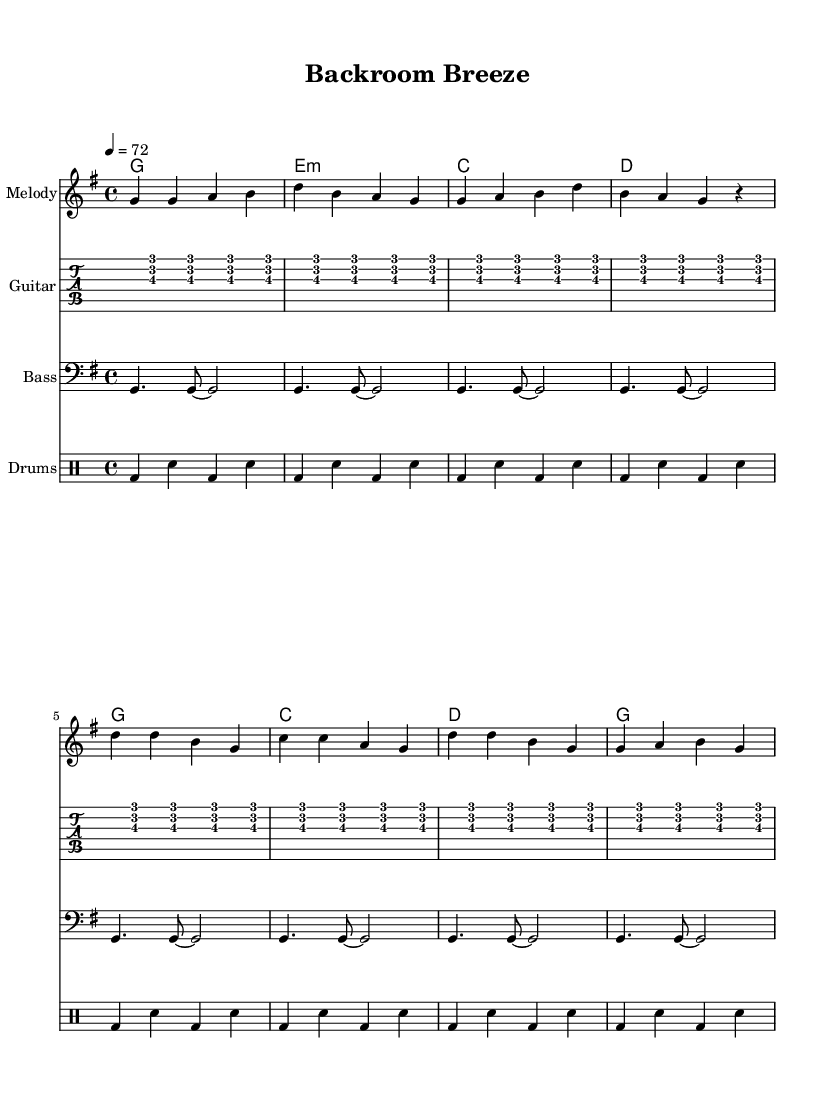What is the key signature of this music? The key signature is G major, which has one sharp (F#). This can be identified at the beginning of the staff where the key signature symbol is displayed.
Answer: G major What is the time signature of this music? The time signature is 4/4, indicated at the start of the music. This means there are four beats in each measure, and a quarter note gets one beat.
Answer: 4/4 What is the tempo marking for this piece? The tempo marking indicates a speed of 72 beats per minute. This can be found in the tempo instruction at the beginning, reading "4 = 72."
Answer: 72 How many measures are in the melody? There are 8 measures in the melody section. By counting the separated groups of notes, each group represents one measure.
Answer: 8 What chord follows the G major chord in the progression? The chord progression indicates that after G major, the next chord is E minor, as shown in the chord names under the staff.
Answer: E minor What is the primary rhythm pattern used in the drum part? The primary rhythm pattern alternates between bass drum and snare drum, producing a steady beat. This is consistent throughout the drum section, characterized by the sequence of bass and snare notes.
Answer: Bass and snare What kind of feel does the guitar part contribute to the reggae style? The guitar part adds a laid-back, off-beat strumming pattern, which is typical of reggae music. This offbeat accentuation contributes to the relaxed vibe associated with reggae.
Answer: Laid-back 